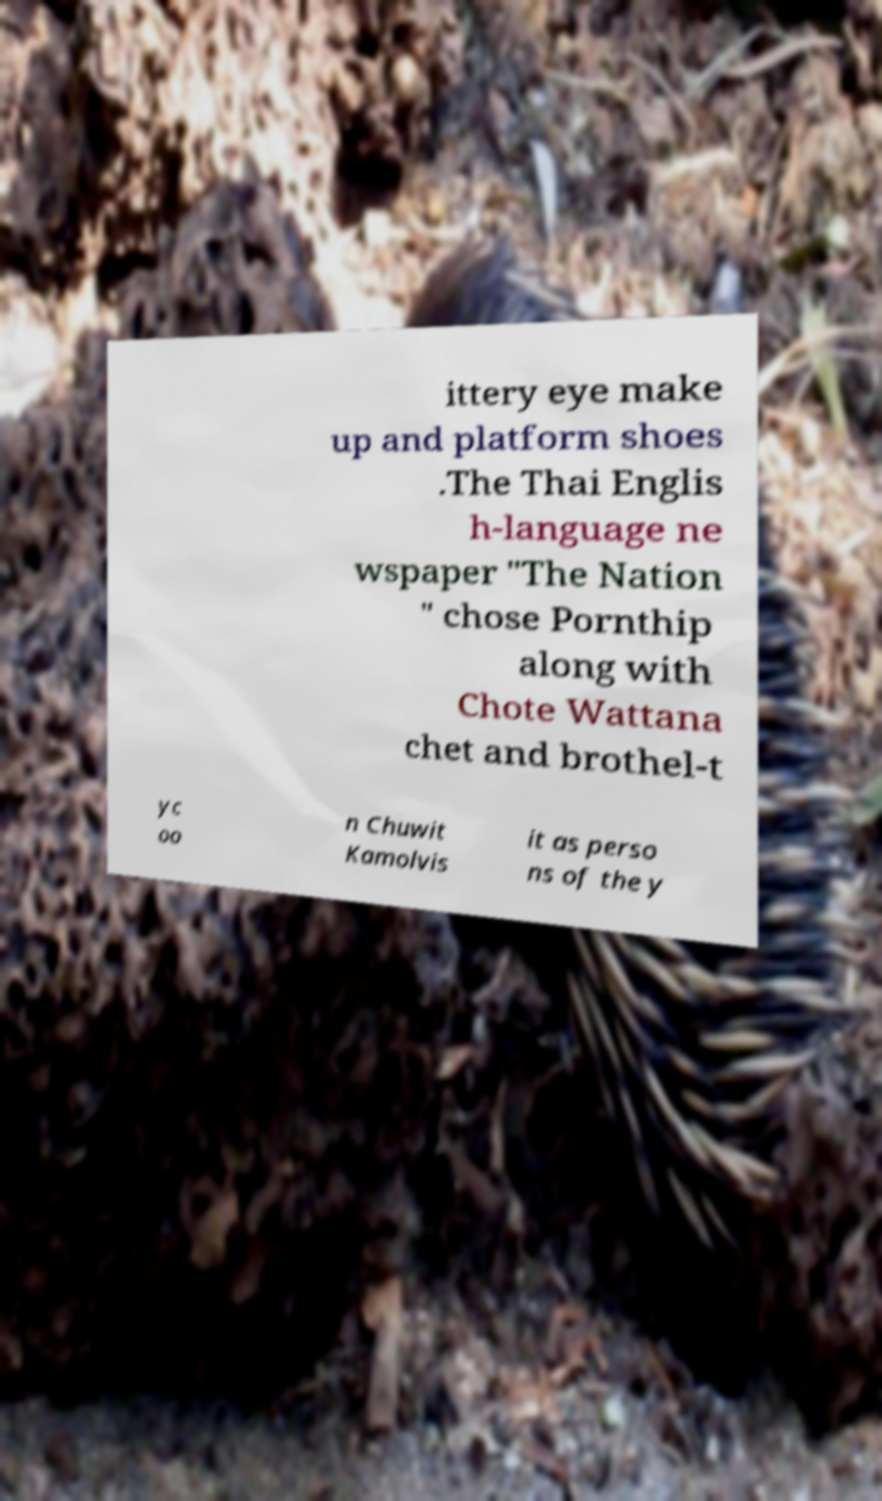Could you assist in decoding the text presented in this image and type it out clearly? ittery eye make up and platform shoes .The Thai Englis h-language ne wspaper "The Nation " chose Pornthip along with Chote Wattana chet and brothel-t yc oo n Chuwit Kamolvis it as perso ns of the y 